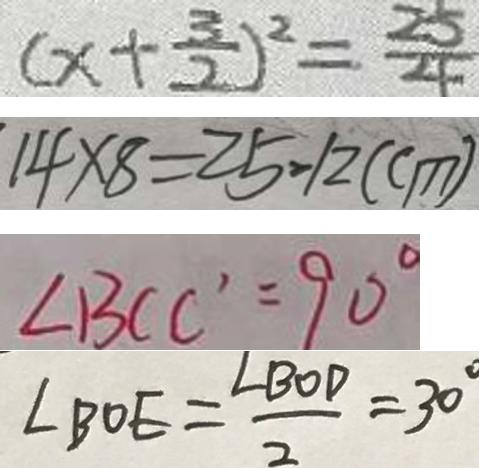<formula> <loc_0><loc_0><loc_500><loc_500>( x + \frac { 3 } { 2 } ) ^ { 2 } = \frac { 2 5 } { 4 } 
 1 4 \times 8 = 2 5 - 1 2 ( c m ) 
 \angle B C C ^ { \prime } = 9 0 ^ { \circ } 
 \angle B O E = \frac { \angle B O D } { 2 } = 3 0 ^ { \circ }</formula> 